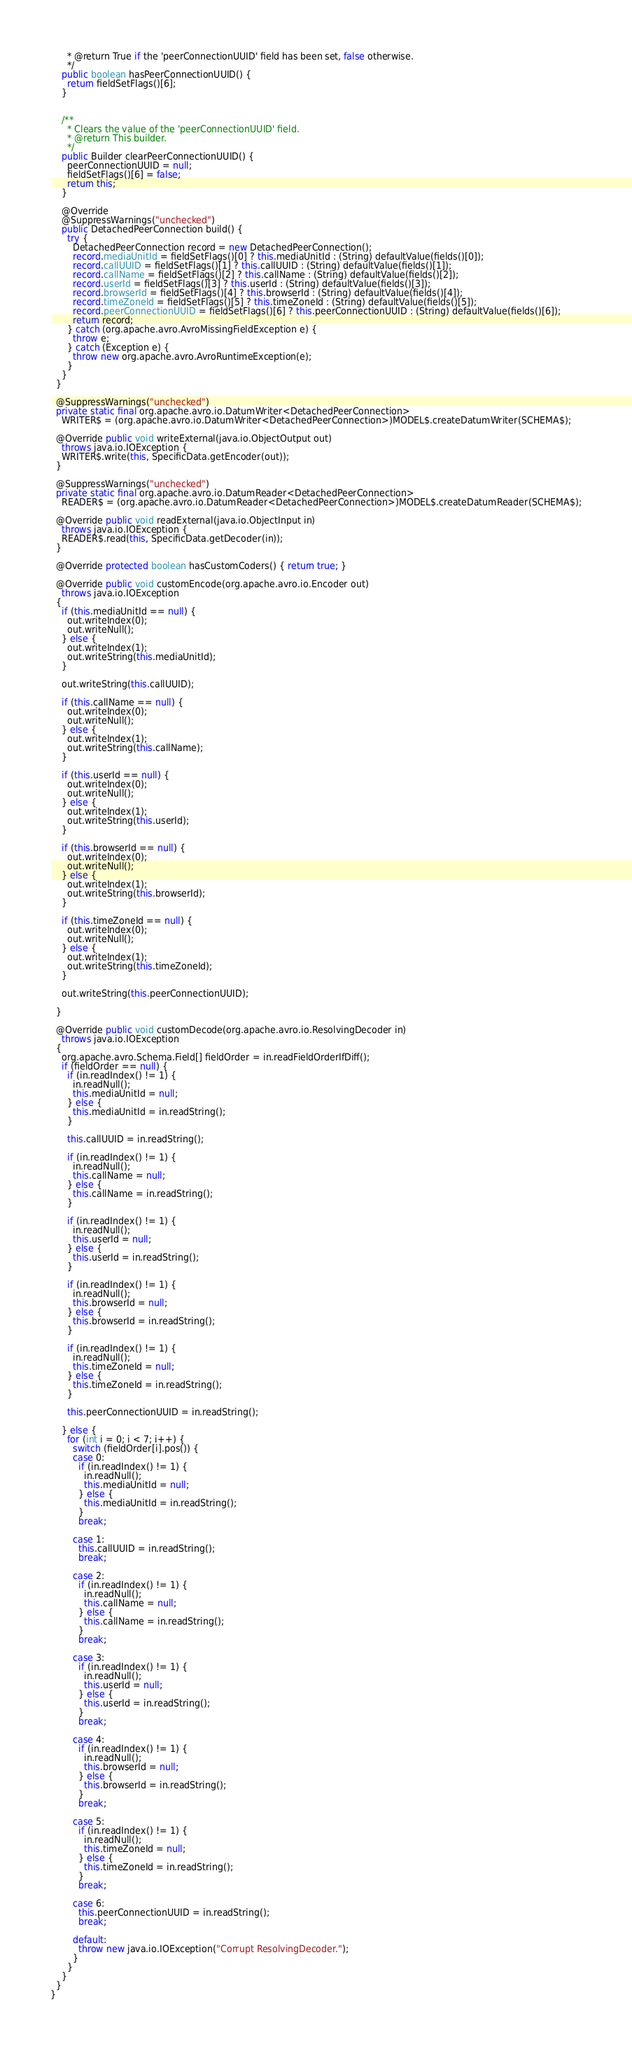<code> <loc_0><loc_0><loc_500><loc_500><_Java_>      * @return True if the 'peerConnectionUUID' field has been set, false otherwise.
      */
    public boolean hasPeerConnectionUUID() {
      return fieldSetFlags()[6];
    }


    /**
      * Clears the value of the 'peerConnectionUUID' field.
      * @return This builder.
      */
    public Builder clearPeerConnectionUUID() {
      peerConnectionUUID = null;
      fieldSetFlags()[6] = false;
      return this;
    }

    @Override
    @SuppressWarnings("unchecked")
    public DetachedPeerConnection build() {
      try {
        DetachedPeerConnection record = new DetachedPeerConnection();
        record.mediaUnitId = fieldSetFlags()[0] ? this.mediaUnitId : (String) defaultValue(fields()[0]);
        record.callUUID = fieldSetFlags()[1] ? this.callUUID : (String) defaultValue(fields()[1]);
        record.callName = fieldSetFlags()[2] ? this.callName : (String) defaultValue(fields()[2]);
        record.userId = fieldSetFlags()[3] ? this.userId : (String) defaultValue(fields()[3]);
        record.browserId = fieldSetFlags()[4] ? this.browserId : (String) defaultValue(fields()[4]);
        record.timeZoneId = fieldSetFlags()[5] ? this.timeZoneId : (String) defaultValue(fields()[5]);
        record.peerConnectionUUID = fieldSetFlags()[6] ? this.peerConnectionUUID : (String) defaultValue(fields()[6]);
        return record;
      } catch (org.apache.avro.AvroMissingFieldException e) {
        throw e;
      } catch (Exception e) {
        throw new org.apache.avro.AvroRuntimeException(e);
      }
    }
  }

  @SuppressWarnings("unchecked")
  private static final org.apache.avro.io.DatumWriter<DetachedPeerConnection>
    WRITER$ = (org.apache.avro.io.DatumWriter<DetachedPeerConnection>)MODEL$.createDatumWriter(SCHEMA$);

  @Override public void writeExternal(java.io.ObjectOutput out)
    throws java.io.IOException {
    WRITER$.write(this, SpecificData.getEncoder(out));
  }

  @SuppressWarnings("unchecked")
  private static final org.apache.avro.io.DatumReader<DetachedPeerConnection>
    READER$ = (org.apache.avro.io.DatumReader<DetachedPeerConnection>)MODEL$.createDatumReader(SCHEMA$);

  @Override public void readExternal(java.io.ObjectInput in)
    throws java.io.IOException {
    READER$.read(this, SpecificData.getDecoder(in));
  }

  @Override protected boolean hasCustomCoders() { return true; }

  @Override public void customEncode(org.apache.avro.io.Encoder out)
    throws java.io.IOException
  {
    if (this.mediaUnitId == null) {
      out.writeIndex(0);
      out.writeNull();
    } else {
      out.writeIndex(1);
      out.writeString(this.mediaUnitId);
    }

    out.writeString(this.callUUID);

    if (this.callName == null) {
      out.writeIndex(0);
      out.writeNull();
    } else {
      out.writeIndex(1);
      out.writeString(this.callName);
    }

    if (this.userId == null) {
      out.writeIndex(0);
      out.writeNull();
    } else {
      out.writeIndex(1);
      out.writeString(this.userId);
    }

    if (this.browserId == null) {
      out.writeIndex(0);
      out.writeNull();
    } else {
      out.writeIndex(1);
      out.writeString(this.browserId);
    }

    if (this.timeZoneId == null) {
      out.writeIndex(0);
      out.writeNull();
    } else {
      out.writeIndex(1);
      out.writeString(this.timeZoneId);
    }

    out.writeString(this.peerConnectionUUID);

  }

  @Override public void customDecode(org.apache.avro.io.ResolvingDecoder in)
    throws java.io.IOException
  {
    org.apache.avro.Schema.Field[] fieldOrder = in.readFieldOrderIfDiff();
    if (fieldOrder == null) {
      if (in.readIndex() != 1) {
        in.readNull();
        this.mediaUnitId = null;
      } else {
        this.mediaUnitId = in.readString();
      }

      this.callUUID = in.readString();

      if (in.readIndex() != 1) {
        in.readNull();
        this.callName = null;
      } else {
        this.callName = in.readString();
      }

      if (in.readIndex() != 1) {
        in.readNull();
        this.userId = null;
      } else {
        this.userId = in.readString();
      }

      if (in.readIndex() != 1) {
        in.readNull();
        this.browserId = null;
      } else {
        this.browserId = in.readString();
      }

      if (in.readIndex() != 1) {
        in.readNull();
        this.timeZoneId = null;
      } else {
        this.timeZoneId = in.readString();
      }

      this.peerConnectionUUID = in.readString();

    } else {
      for (int i = 0; i < 7; i++) {
        switch (fieldOrder[i].pos()) {
        case 0:
          if (in.readIndex() != 1) {
            in.readNull();
            this.mediaUnitId = null;
          } else {
            this.mediaUnitId = in.readString();
          }
          break;

        case 1:
          this.callUUID = in.readString();
          break;

        case 2:
          if (in.readIndex() != 1) {
            in.readNull();
            this.callName = null;
          } else {
            this.callName = in.readString();
          }
          break;

        case 3:
          if (in.readIndex() != 1) {
            in.readNull();
            this.userId = null;
          } else {
            this.userId = in.readString();
          }
          break;

        case 4:
          if (in.readIndex() != 1) {
            in.readNull();
            this.browserId = null;
          } else {
            this.browserId = in.readString();
          }
          break;

        case 5:
          if (in.readIndex() != 1) {
            in.readNull();
            this.timeZoneId = null;
          } else {
            this.timeZoneId = in.readString();
          }
          break;

        case 6:
          this.peerConnectionUUID = in.readString();
          break;

        default:
          throw new java.io.IOException("Corrupt ResolvingDecoder.");
        }
      }
    }
  }
}










</code> 